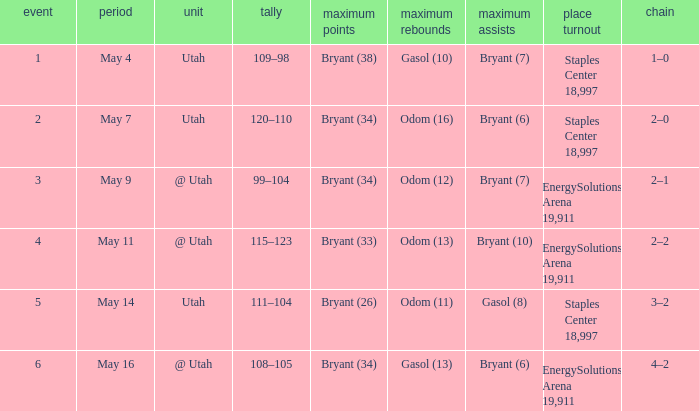What is the Series with a High rebounds with gasol (10)? 1–0. 